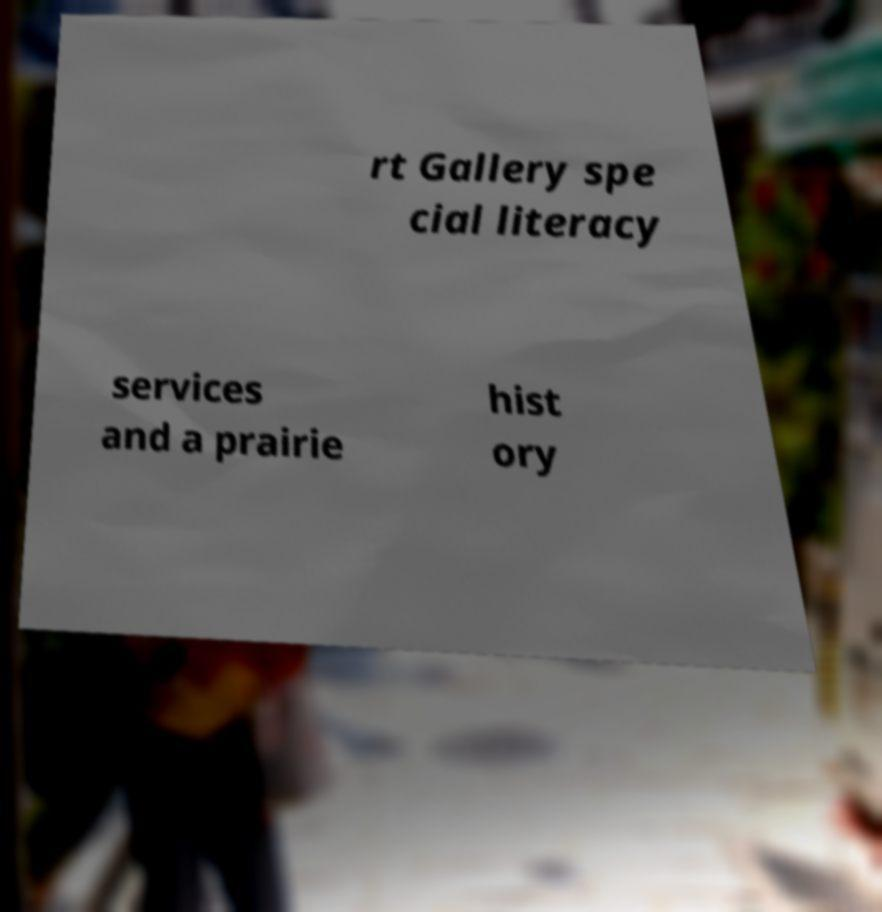I need the written content from this picture converted into text. Can you do that? rt Gallery spe cial literacy services and a prairie hist ory 